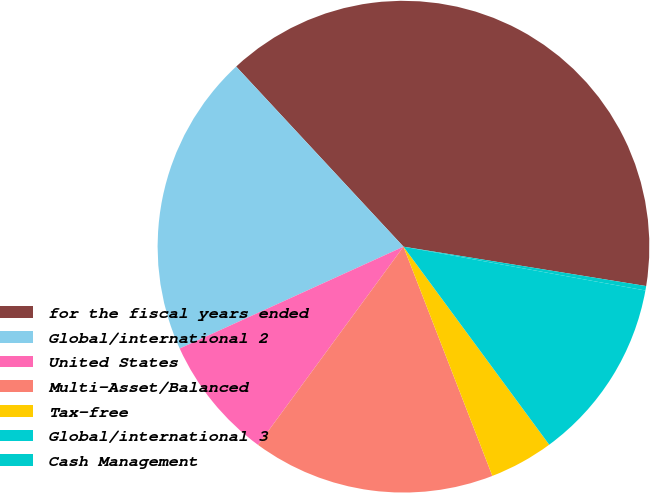Convert chart. <chart><loc_0><loc_0><loc_500><loc_500><pie_chart><fcel>for the fiscal years ended<fcel>Global/international 2<fcel>United States<fcel>Multi-Asset/Balanced<fcel>Tax-free<fcel>Global/international 3<fcel>Cash Management<nl><fcel>39.47%<fcel>19.88%<fcel>8.13%<fcel>15.96%<fcel>4.21%<fcel>12.05%<fcel>0.29%<nl></chart> 